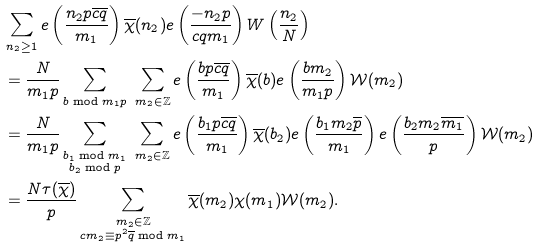Convert formula to latex. <formula><loc_0><loc_0><loc_500><loc_500>& \sum _ { n _ { 2 } \geq 1 } e \left ( \frac { n _ { 2 } p \overline { c q } } { m _ { 1 } } \right ) \overline { \chi } ( n _ { 2 } ) e \left ( \frac { - n _ { 2 } p } { c q m _ { 1 } } \right ) W \left ( \frac { n _ { 2 } } { N } \right ) \\ & = \frac { N } { m _ { 1 } p } \sum _ { b \bmod m _ { 1 } p } \ \sum _ { m _ { 2 } \in \mathbb { Z } } e \left ( \frac { b p \overline { c q } } { m _ { 1 } } \right ) \overline { \chi } ( b ) e \left ( \frac { b m _ { 2 } } { m _ { 1 } p } \right ) \mathcal { W } ( m _ { 2 } ) \\ & = \frac { N } { m _ { 1 } p } \sum _ { \substack { b _ { 1 } \bmod m _ { 1 } \\ b _ { 2 } \bmod p } } \ \sum _ { m _ { 2 } \in \mathbb { Z } } e \left ( \frac { b _ { 1 } p \overline { c q } } { m _ { 1 } } \right ) \overline { \chi } ( b _ { 2 } ) e \left ( \frac { b _ { 1 } m _ { 2 } \overline { p } } { m _ { 1 } } \right ) e \left ( \frac { b _ { 2 } m _ { 2 } \overline { m _ { 1 } } } { p } \right ) \mathcal { W } ( m _ { 2 } ) \\ & = \frac { N \tau ( \overline { \chi } ) } { p } \sum _ { \substack { m _ { 2 } \in \mathbb { Z } \\ c m _ { 2 } \equiv p ^ { 2 } \overline { q } \bmod m _ { 1 } } } \overline { \chi } ( m _ { 2 } ) \chi ( m _ { 1 } ) \mathcal { W } ( m _ { 2 } ) .</formula> 